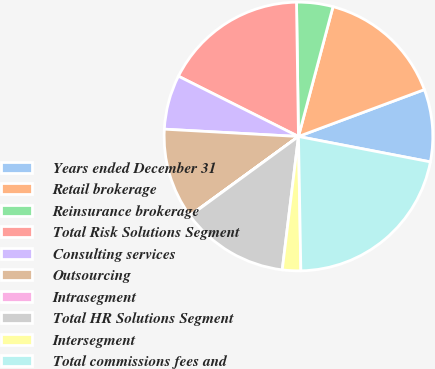Convert chart to OTSL. <chart><loc_0><loc_0><loc_500><loc_500><pie_chart><fcel>Years ended December 31<fcel>Retail brokerage<fcel>Reinsurance brokerage<fcel>Total Risk Solutions Segment<fcel>Consulting services<fcel>Outsourcing<fcel>Intrasegment<fcel>Total HR Solutions Segment<fcel>Intersegment<fcel>Total commissions fees and<nl><fcel>8.7%<fcel>15.19%<fcel>4.37%<fcel>17.36%<fcel>6.54%<fcel>10.87%<fcel>0.04%<fcel>13.03%<fcel>2.21%<fcel>21.69%<nl></chart> 